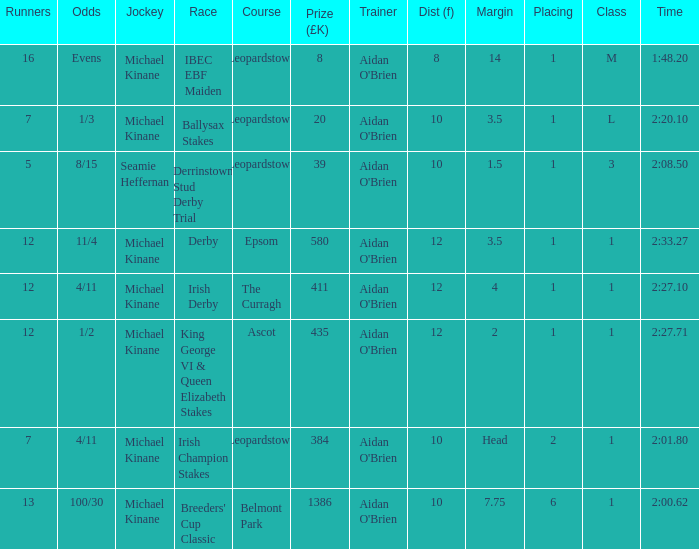Which Dist (f) has a Race of irish derby? 12.0. 